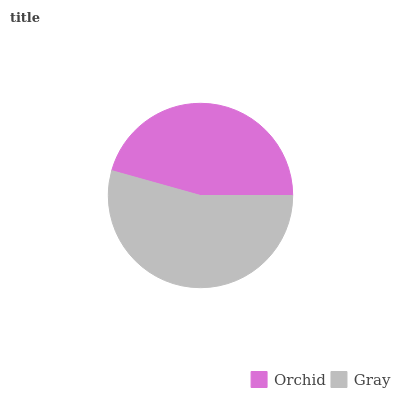Is Orchid the minimum?
Answer yes or no. Yes. Is Gray the maximum?
Answer yes or no. Yes. Is Gray the minimum?
Answer yes or no. No. Is Gray greater than Orchid?
Answer yes or no. Yes. Is Orchid less than Gray?
Answer yes or no. Yes. Is Orchid greater than Gray?
Answer yes or no. No. Is Gray less than Orchid?
Answer yes or no. No. Is Gray the high median?
Answer yes or no. Yes. Is Orchid the low median?
Answer yes or no. Yes. Is Orchid the high median?
Answer yes or no. No. Is Gray the low median?
Answer yes or no. No. 